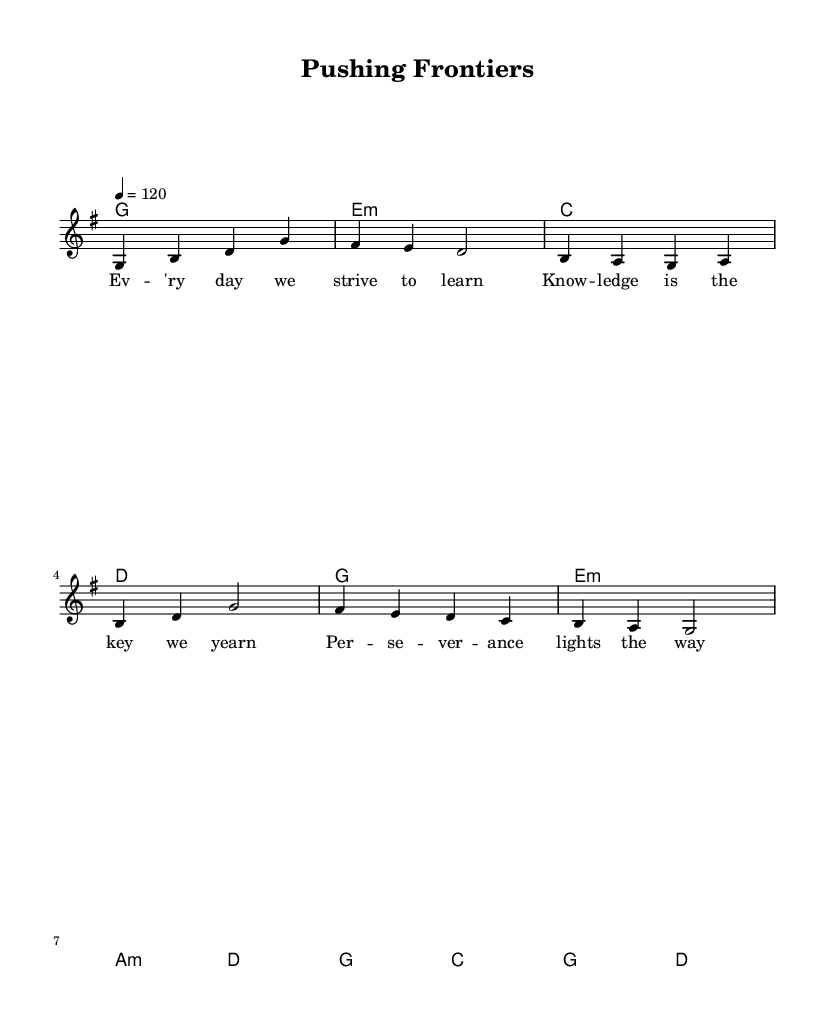What is the key signature of this music? The key signature indicates that the piece is in G major, which has one sharp (F#). This is apparent from the absence of flats or additional sharps indicated with the notes.
Answer: G major What is the time signature of this music? The time signature is 4/4, which means there are four beats per measure, as evident from the notational information indicated in the code.
Answer: 4/4 What is the tempo marking for this piece? The tempo for this music is set at 120 beats per minute, as specified in the tempo directive within the score code.
Answer: 120 How many measures are in the melody? By counting the individual measures marked with vertical lines in the melody section, there are a total of 6 measures, as shown by the grouping of notes.
Answer: 6 measures What type of song does this music represent? The song represents a motivational theme focused on perseverance, as interpreted from the lyrics that emphasize striving for knowledge and persistence.
Answer: Motivational Which chord appears most frequently in the harmonies? By evaluating the chords listed in the chordmode, the G major chord appears the most frequently, occurring multiple times throughout the piece.
Answer: G What lyrical theme is presented in the first verse? The first verse focuses on the importance of striving to learn and the yearning for knowledge, articulated in the lyrics that emphasize perseverance and dedication.
Answer: Striving for knowledge 